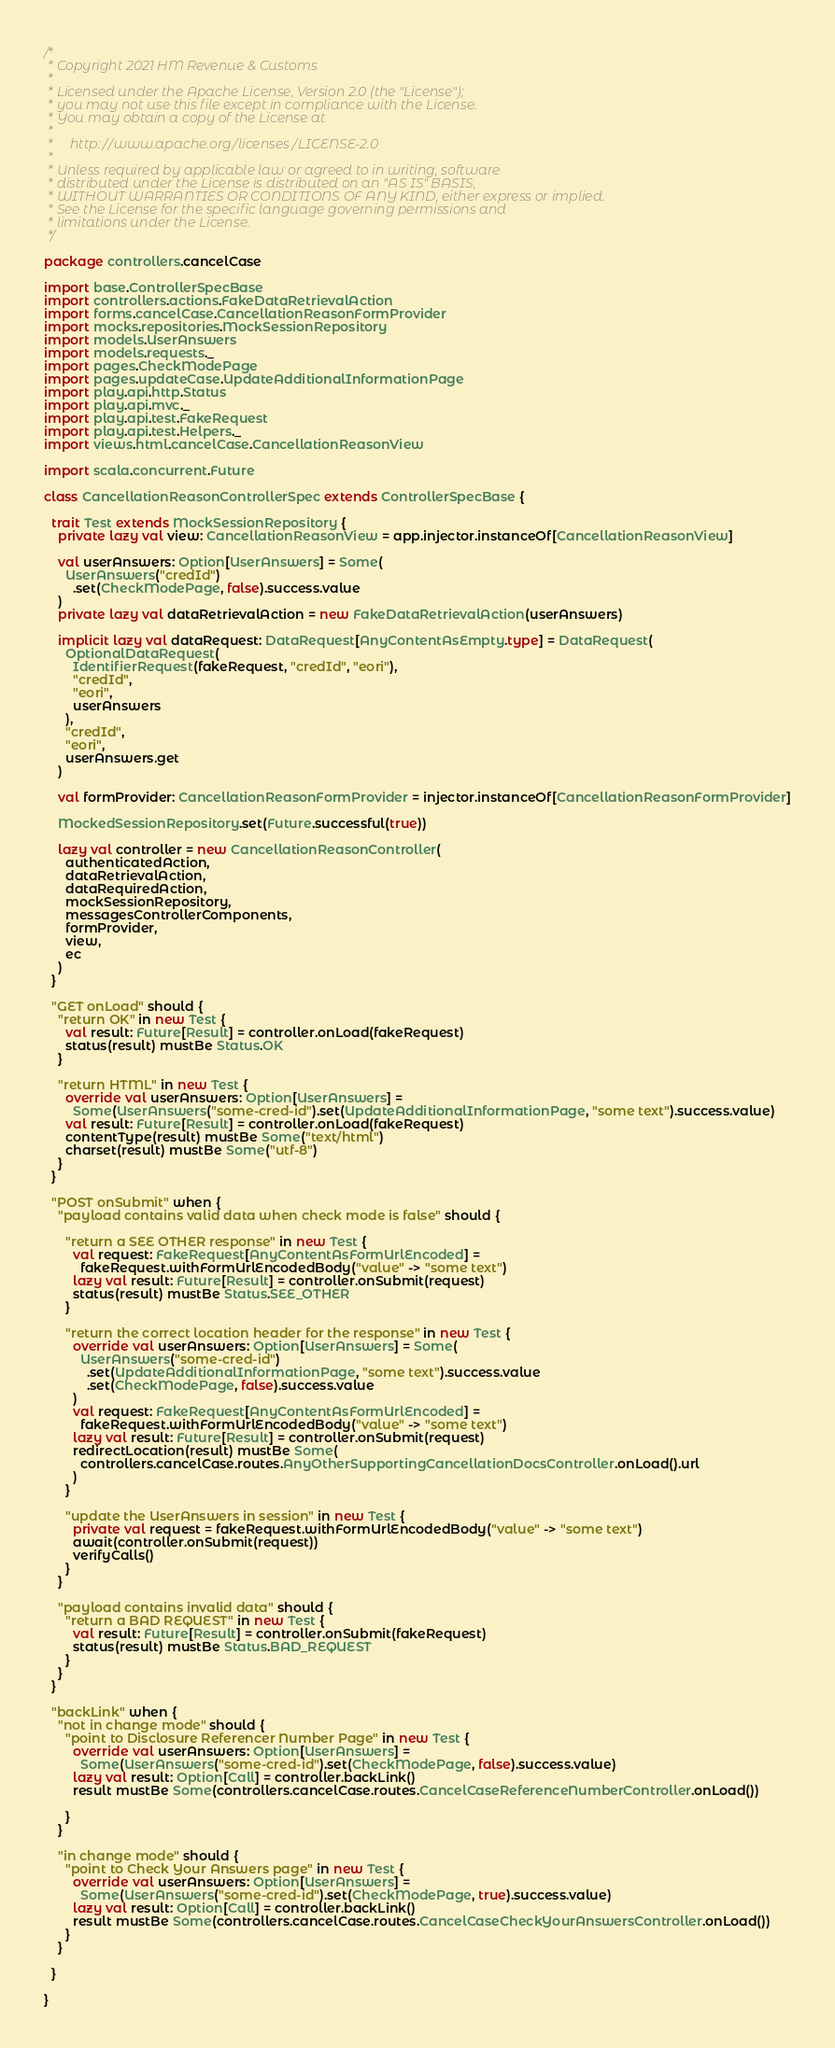<code> <loc_0><loc_0><loc_500><loc_500><_Scala_>/*
 * Copyright 2021 HM Revenue & Customs
 *
 * Licensed under the Apache License, Version 2.0 (the "License");
 * you may not use this file except in compliance with the License.
 * You may obtain a copy of the License at
 *
 *     http://www.apache.org/licenses/LICENSE-2.0
 *
 * Unless required by applicable law or agreed to in writing, software
 * distributed under the License is distributed on an "AS IS" BASIS,
 * WITHOUT WARRANTIES OR CONDITIONS OF ANY KIND, either express or implied.
 * See the License for the specific language governing permissions and
 * limitations under the License.
 */

package controllers.cancelCase

import base.ControllerSpecBase
import controllers.actions.FakeDataRetrievalAction
import forms.cancelCase.CancellationReasonFormProvider
import mocks.repositories.MockSessionRepository
import models.UserAnswers
import models.requests._
import pages.CheckModePage
import pages.updateCase.UpdateAdditionalInformationPage
import play.api.http.Status
import play.api.mvc._
import play.api.test.FakeRequest
import play.api.test.Helpers._
import views.html.cancelCase.CancellationReasonView

import scala.concurrent.Future

class CancellationReasonControllerSpec extends ControllerSpecBase {

  trait Test extends MockSessionRepository {
    private lazy val view: CancellationReasonView = app.injector.instanceOf[CancellationReasonView]

    val userAnswers: Option[UserAnswers] = Some(
      UserAnswers("credId")
        .set(CheckModePage, false).success.value
    )
    private lazy val dataRetrievalAction = new FakeDataRetrievalAction(userAnswers)

    implicit lazy val dataRequest: DataRequest[AnyContentAsEmpty.type] = DataRequest(
      OptionalDataRequest(
        IdentifierRequest(fakeRequest, "credId", "eori"),
        "credId",
        "eori",
        userAnswers
      ),
      "credId",
      "eori",
      userAnswers.get
    )

    val formProvider: CancellationReasonFormProvider = injector.instanceOf[CancellationReasonFormProvider]

    MockedSessionRepository.set(Future.successful(true))

    lazy val controller = new CancellationReasonController(
      authenticatedAction,
      dataRetrievalAction,
      dataRequiredAction,
      mockSessionRepository,
      messagesControllerComponents,
      formProvider,
      view,
      ec
    )
  }

  "GET onLoad" should {
    "return OK" in new Test {
      val result: Future[Result] = controller.onLoad(fakeRequest)
      status(result) mustBe Status.OK
    }

    "return HTML" in new Test {
      override val userAnswers: Option[UserAnswers] =
        Some(UserAnswers("some-cred-id").set(UpdateAdditionalInformationPage, "some text").success.value)
      val result: Future[Result] = controller.onLoad(fakeRequest)
      contentType(result) mustBe Some("text/html")
      charset(result) mustBe Some("utf-8")
    }
  }

  "POST onSubmit" when {
    "payload contains valid data when check mode is false" should {

      "return a SEE OTHER response" in new Test {
        val request: FakeRequest[AnyContentAsFormUrlEncoded] =
          fakeRequest.withFormUrlEncodedBody("value" -> "some text")
        lazy val result: Future[Result] = controller.onSubmit(request)
        status(result) mustBe Status.SEE_OTHER
      }

      "return the correct location header for the response" in new Test {
        override val userAnswers: Option[UserAnswers] = Some(
          UserAnswers("some-cred-id")
            .set(UpdateAdditionalInformationPage, "some text").success.value
            .set(CheckModePage, false).success.value
        )
        val request: FakeRequest[AnyContentAsFormUrlEncoded] =
          fakeRequest.withFormUrlEncodedBody("value" -> "some text")
        lazy val result: Future[Result] = controller.onSubmit(request)
        redirectLocation(result) mustBe Some(
          controllers.cancelCase.routes.AnyOtherSupportingCancellationDocsController.onLoad().url
        )
      }

      "update the UserAnswers in session" in new Test {
        private val request = fakeRequest.withFormUrlEncodedBody("value" -> "some text")
        await(controller.onSubmit(request))
        verifyCalls()
      }
    }

    "payload contains invalid data" should {
      "return a BAD REQUEST" in new Test {
        val result: Future[Result] = controller.onSubmit(fakeRequest)
        status(result) mustBe Status.BAD_REQUEST
      }
    }
  }

  "backLink" when {
    "not in change mode" should {
      "point to Disclosure Referencer Number Page" in new Test {
        override val userAnswers: Option[UserAnswers] =
          Some(UserAnswers("some-cred-id").set(CheckModePage, false).success.value)
        lazy val result: Option[Call] = controller.backLink()
        result mustBe Some(controllers.cancelCase.routes.CancelCaseReferenceNumberController.onLoad())

      }
    }

    "in change mode" should {
      "point to Check Your Answers page" in new Test {
        override val userAnswers: Option[UserAnswers] =
          Some(UserAnswers("some-cred-id").set(CheckModePage, true).success.value)
        lazy val result: Option[Call] = controller.backLink()
        result mustBe Some(controllers.cancelCase.routes.CancelCaseCheckYourAnswersController.onLoad())
      }
    }

  }

}
</code> 